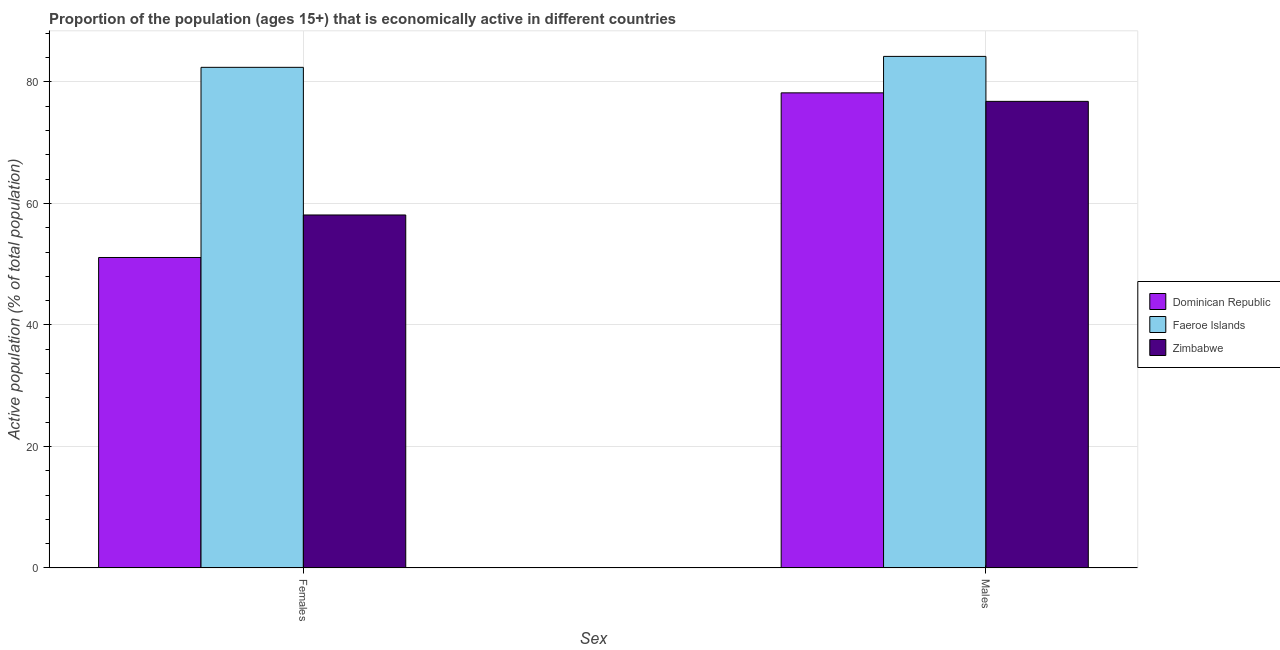How many different coloured bars are there?
Your answer should be compact. 3. Are the number of bars on each tick of the X-axis equal?
Offer a very short reply. Yes. How many bars are there on the 1st tick from the left?
Your answer should be compact. 3. How many bars are there on the 2nd tick from the right?
Make the answer very short. 3. What is the label of the 1st group of bars from the left?
Your response must be concise. Females. What is the percentage of economically active female population in Faeroe Islands?
Offer a terse response. 82.4. Across all countries, what is the maximum percentage of economically active male population?
Offer a very short reply. 84.2. Across all countries, what is the minimum percentage of economically active female population?
Offer a very short reply. 51.1. In which country was the percentage of economically active female population maximum?
Your answer should be compact. Faeroe Islands. In which country was the percentage of economically active male population minimum?
Your answer should be compact. Zimbabwe. What is the total percentage of economically active female population in the graph?
Provide a succinct answer. 191.6. What is the difference between the percentage of economically active female population in Zimbabwe and that in Faeroe Islands?
Your answer should be very brief. -24.3. What is the difference between the percentage of economically active male population in Zimbabwe and the percentage of economically active female population in Faeroe Islands?
Give a very brief answer. -5.6. What is the average percentage of economically active female population per country?
Provide a short and direct response. 63.87. What is the difference between the percentage of economically active male population and percentage of economically active female population in Dominican Republic?
Ensure brevity in your answer.  27.1. In how many countries, is the percentage of economically active female population greater than 44 %?
Your response must be concise. 3. What is the ratio of the percentage of economically active female population in Zimbabwe to that in Dominican Republic?
Ensure brevity in your answer.  1.14. In how many countries, is the percentage of economically active male population greater than the average percentage of economically active male population taken over all countries?
Your response must be concise. 1. What does the 1st bar from the left in Females represents?
Provide a short and direct response. Dominican Republic. What does the 3rd bar from the right in Females represents?
Give a very brief answer. Dominican Republic. How many bars are there?
Offer a very short reply. 6. Are all the bars in the graph horizontal?
Your answer should be very brief. No. How many countries are there in the graph?
Keep it short and to the point. 3. What is the difference between two consecutive major ticks on the Y-axis?
Provide a succinct answer. 20. Where does the legend appear in the graph?
Offer a terse response. Center right. How many legend labels are there?
Your answer should be compact. 3. What is the title of the graph?
Keep it short and to the point. Proportion of the population (ages 15+) that is economically active in different countries. Does "Belize" appear as one of the legend labels in the graph?
Your response must be concise. No. What is the label or title of the X-axis?
Offer a terse response. Sex. What is the label or title of the Y-axis?
Make the answer very short. Active population (% of total population). What is the Active population (% of total population) in Dominican Republic in Females?
Your answer should be compact. 51.1. What is the Active population (% of total population) of Faeroe Islands in Females?
Ensure brevity in your answer.  82.4. What is the Active population (% of total population) in Zimbabwe in Females?
Make the answer very short. 58.1. What is the Active population (% of total population) of Dominican Republic in Males?
Provide a succinct answer. 78.2. What is the Active population (% of total population) of Faeroe Islands in Males?
Make the answer very short. 84.2. What is the Active population (% of total population) in Zimbabwe in Males?
Keep it short and to the point. 76.8. Across all Sex, what is the maximum Active population (% of total population) of Dominican Republic?
Provide a short and direct response. 78.2. Across all Sex, what is the maximum Active population (% of total population) in Faeroe Islands?
Keep it short and to the point. 84.2. Across all Sex, what is the maximum Active population (% of total population) of Zimbabwe?
Give a very brief answer. 76.8. Across all Sex, what is the minimum Active population (% of total population) of Dominican Republic?
Offer a terse response. 51.1. Across all Sex, what is the minimum Active population (% of total population) of Faeroe Islands?
Ensure brevity in your answer.  82.4. Across all Sex, what is the minimum Active population (% of total population) in Zimbabwe?
Offer a terse response. 58.1. What is the total Active population (% of total population) in Dominican Republic in the graph?
Ensure brevity in your answer.  129.3. What is the total Active population (% of total population) of Faeroe Islands in the graph?
Provide a succinct answer. 166.6. What is the total Active population (% of total population) in Zimbabwe in the graph?
Offer a very short reply. 134.9. What is the difference between the Active population (% of total population) of Dominican Republic in Females and that in Males?
Offer a terse response. -27.1. What is the difference between the Active population (% of total population) of Zimbabwe in Females and that in Males?
Ensure brevity in your answer.  -18.7. What is the difference between the Active population (% of total population) of Dominican Republic in Females and the Active population (% of total population) of Faeroe Islands in Males?
Your answer should be very brief. -33.1. What is the difference between the Active population (% of total population) in Dominican Republic in Females and the Active population (% of total population) in Zimbabwe in Males?
Your response must be concise. -25.7. What is the average Active population (% of total population) in Dominican Republic per Sex?
Keep it short and to the point. 64.65. What is the average Active population (% of total population) in Faeroe Islands per Sex?
Offer a very short reply. 83.3. What is the average Active population (% of total population) of Zimbabwe per Sex?
Make the answer very short. 67.45. What is the difference between the Active population (% of total population) of Dominican Republic and Active population (% of total population) of Faeroe Islands in Females?
Provide a succinct answer. -31.3. What is the difference between the Active population (% of total population) in Dominican Republic and Active population (% of total population) in Zimbabwe in Females?
Make the answer very short. -7. What is the difference between the Active population (% of total population) of Faeroe Islands and Active population (% of total population) of Zimbabwe in Females?
Offer a terse response. 24.3. What is the difference between the Active population (% of total population) in Faeroe Islands and Active population (% of total population) in Zimbabwe in Males?
Your response must be concise. 7.4. What is the ratio of the Active population (% of total population) in Dominican Republic in Females to that in Males?
Keep it short and to the point. 0.65. What is the ratio of the Active population (% of total population) in Faeroe Islands in Females to that in Males?
Provide a short and direct response. 0.98. What is the ratio of the Active population (% of total population) in Zimbabwe in Females to that in Males?
Offer a very short reply. 0.76. What is the difference between the highest and the second highest Active population (% of total population) of Dominican Republic?
Ensure brevity in your answer.  27.1. What is the difference between the highest and the second highest Active population (% of total population) of Faeroe Islands?
Ensure brevity in your answer.  1.8. What is the difference between the highest and the second highest Active population (% of total population) in Zimbabwe?
Keep it short and to the point. 18.7. What is the difference between the highest and the lowest Active population (% of total population) in Dominican Republic?
Give a very brief answer. 27.1. What is the difference between the highest and the lowest Active population (% of total population) in Faeroe Islands?
Your answer should be compact. 1.8. What is the difference between the highest and the lowest Active population (% of total population) in Zimbabwe?
Your answer should be very brief. 18.7. 